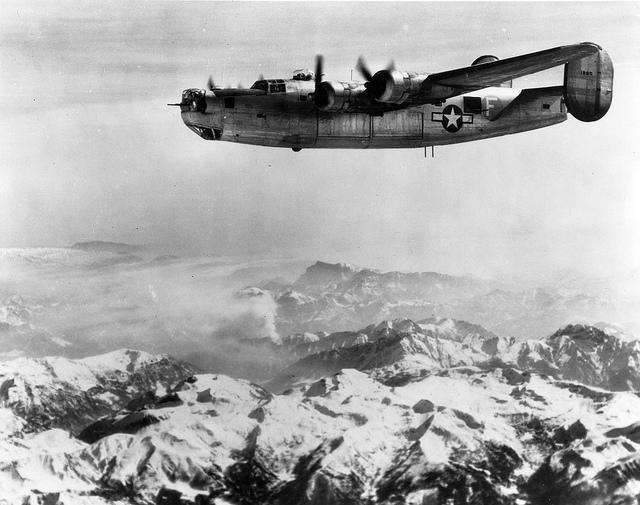How many people are holding camera?
Give a very brief answer. 0. 